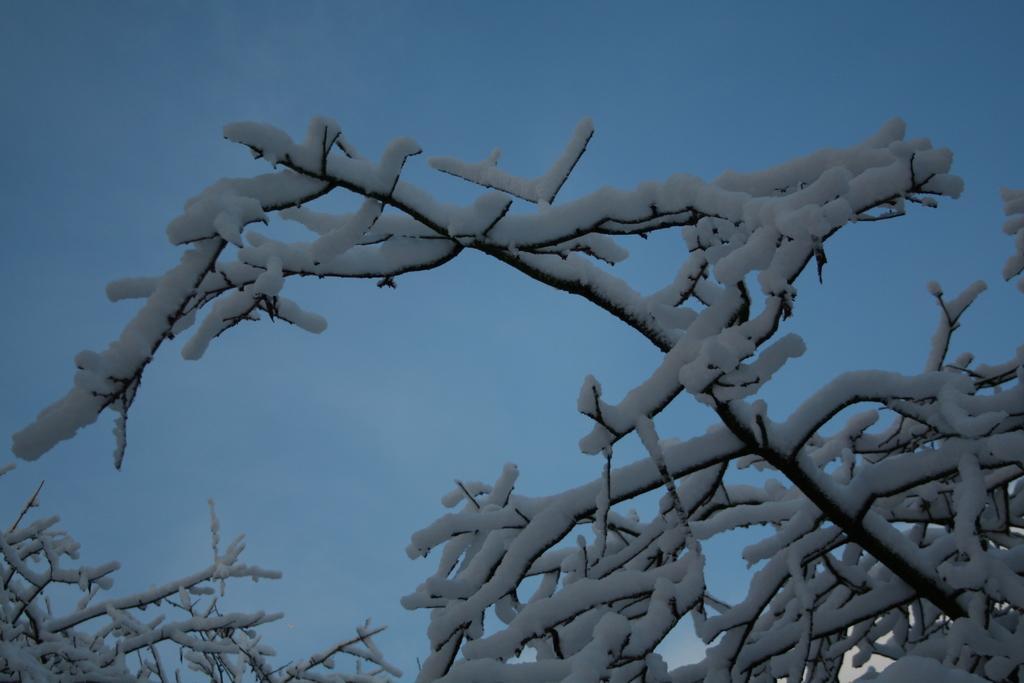Could you give a brief overview of what you see in this image? In this image, this looks like a tree with the branches, which is covered with the snow. I think this is the sky. 